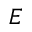<formula> <loc_0><loc_0><loc_500><loc_500>E</formula> 